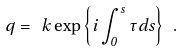<formula> <loc_0><loc_0><loc_500><loc_500>q = \ k \exp \left \{ i \int _ { 0 } ^ { s } \tau d s \right \} \ .</formula> 